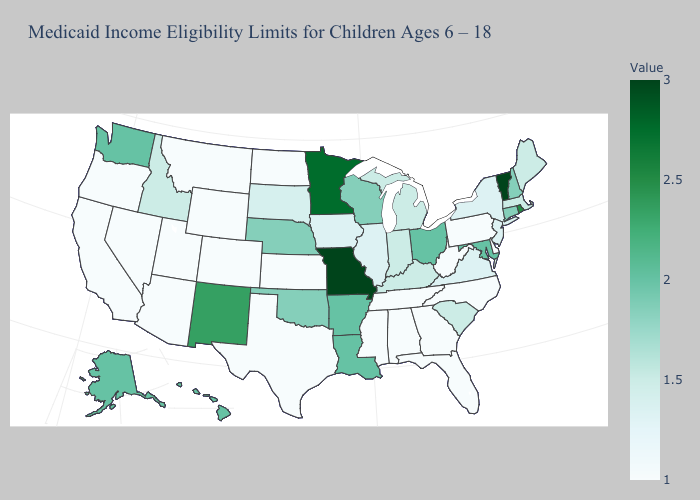Which states have the lowest value in the USA?
Quick response, please. Alabama, Arizona, California, Colorado, Delaware, Florida, Georgia, Kansas, Mississippi, Montana, Nevada, North Carolina, North Dakota, Oregon, Pennsylvania, Tennessee, Texas, Utah, West Virginia, Wyoming. Does Minnesota have the lowest value in the MidWest?
Write a very short answer. No. Among the states that border Georgia , does South Carolina have the highest value?
Be succinct. Yes. Which states hav the highest value in the South?
Answer briefly. Arkansas, Louisiana, Maryland. Does Rhode Island have the lowest value in the USA?
Write a very short answer. No. Does New Hampshire have the highest value in the Northeast?
Quick response, please. No. Does Nebraska have a higher value than Minnesota?
Keep it brief. No. Among the states that border Nevada , which have the highest value?
Quick response, please. Idaho. Does Kentucky have a lower value than Texas?
Keep it brief. No. Does Virginia have the highest value in the South?
Give a very brief answer. No. Is the legend a continuous bar?
Give a very brief answer. Yes. 